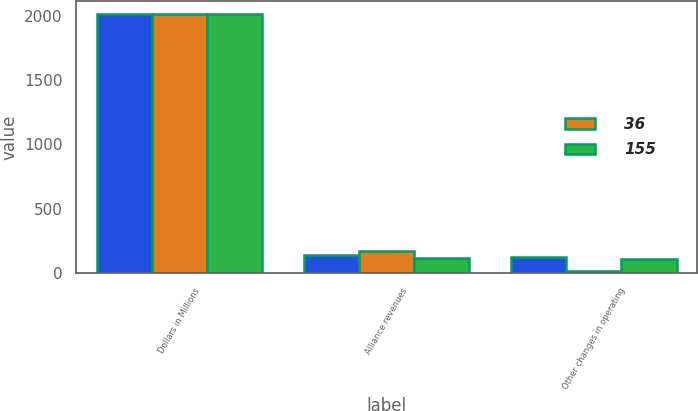<chart> <loc_0><loc_0><loc_500><loc_500><stacked_bar_chart><ecel><fcel>Dollars in Millions<fcel>Alliance revenues<fcel>Other changes in operating<nl><fcel>nan<fcel>2015<fcel>140<fcel>129<nl><fcel>36<fcel>2014<fcel>170<fcel>20<nl><fcel>155<fcel>2013<fcel>116<fcel>109<nl></chart> 